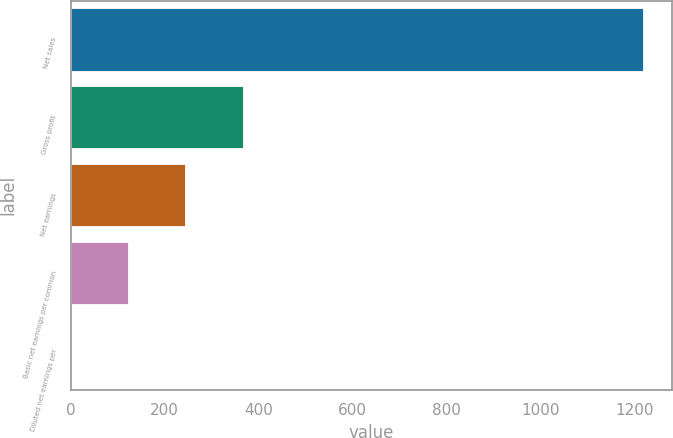Convert chart to OTSL. <chart><loc_0><loc_0><loc_500><loc_500><bar_chart><fcel>Net sales<fcel>Gross profit<fcel>Net earnings<fcel>Basic net earnings per common<fcel>Diluted net earnings per<nl><fcel>1219<fcel>365.75<fcel>243.85<fcel>121.95<fcel>0.05<nl></chart> 